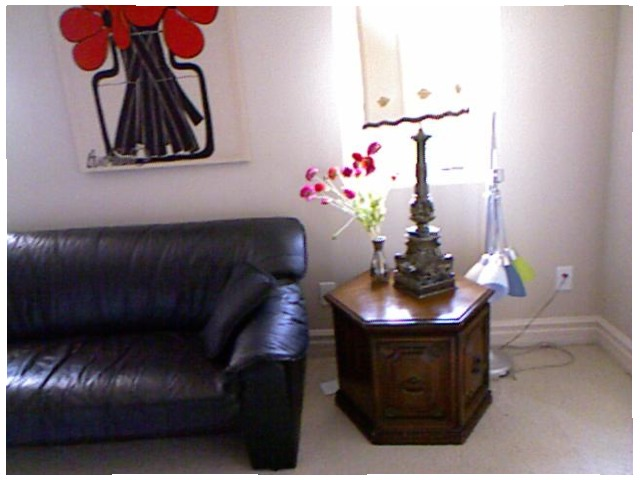<image>
Can you confirm if the flower pot is on the table? Yes. Looking at the image, I can see the flower pot is positioned on top of the table, with the table providing support. Is the paper on the carpet? Yes. Looking at the image, I can see the paper is positioned on top of the carpet, with the carpet providing support. Where is the flowers in relation to the wall? Is it on the wall? No. The flowers is not positioned on the wall. They may be near each other, but the flowers is not supported by or resting on top of the wall. Is the lamp on the floor? No. The lamp is not positioned on the floor. They may be near each other, but the lamp is not supported by or resting on top of the floor. Is the vase behind the lamp? Yes. From this viewpoint, the vase is positioned behind the lamp, with the lamp partially or fully occluding the vase. Is there a painting behind the lamp? No. The painting is not behind the lamp. From this viewpoint, the painting appears to be positioned elsewhere in the scene. Where is the sofa in relation to the table? Is it behind the table? No. The sofa is not behind the table. From this viewpoint, the sofa appears to be positioned elsewhere in the scene. 